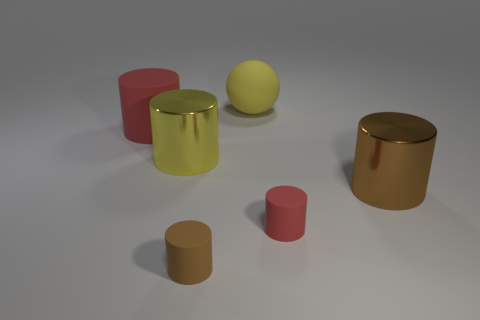Add 1 large yellow spheres. How many objects exist? 7 Subtract all big red matte cylinders. How many cylinders are left? 4 Subtract all brown spheres. How many brown cylinders are left? 2 Subtract all brown cylinders. How many cylinders are left? 3 Subtract all cylinders. How many objects are left? 1 Subtract all large yellow rubber blocks. Subtract all big brown things. How many objects are left? 5 Add 1 metal things. How many metal things are left? 3 Add 6 shiny things. How many shiny things exist? 8 Subtract 0 gray cylinders. How many objects are left? 6 Subtract all purple cylinders. Subtract all brown balls. How many cylinders are left? 5 